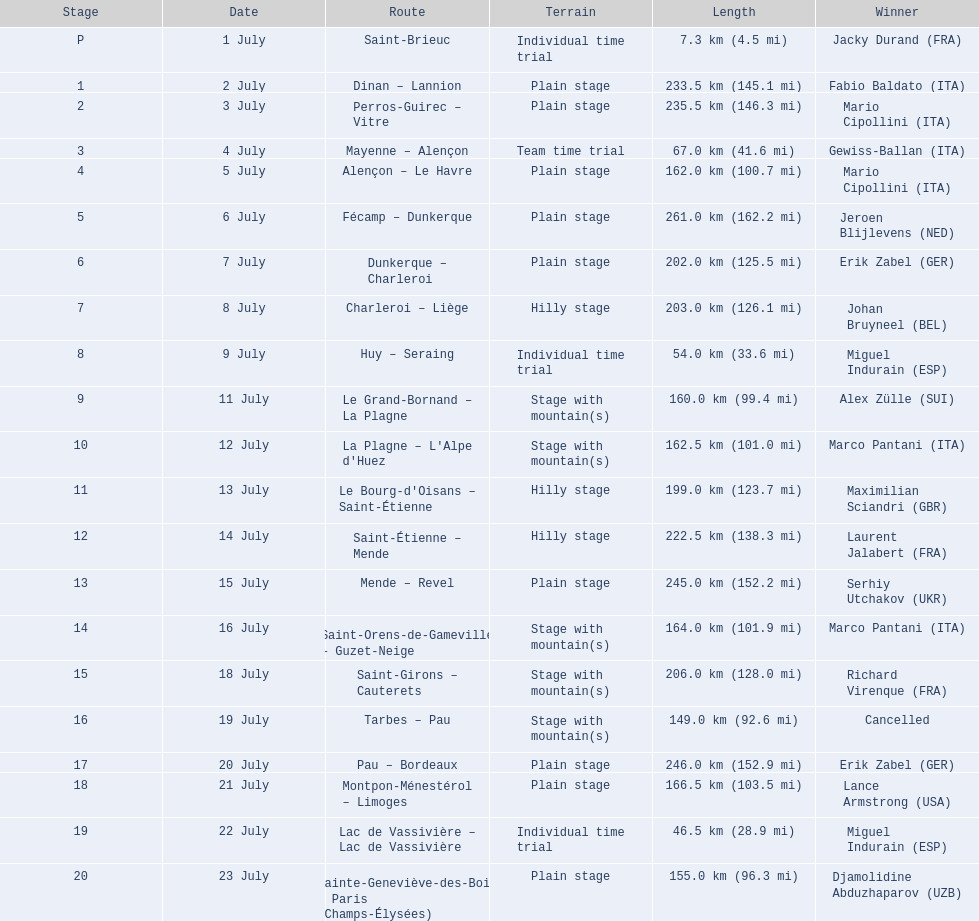During which dates did the 1995 tour de france take place? 1 July, 2 July, 3 July, 4 July, 5 July, 6 July, 7 July, 8 July, 9 July, 11 July, 12 July, 13 July, 14 July, 15 July, 16 July, 18 July, 19 July, 20 July, 21 July, 22 July, 23 July. How long was the stage on the 8th of july? 203.0 km (126.1 mi). 